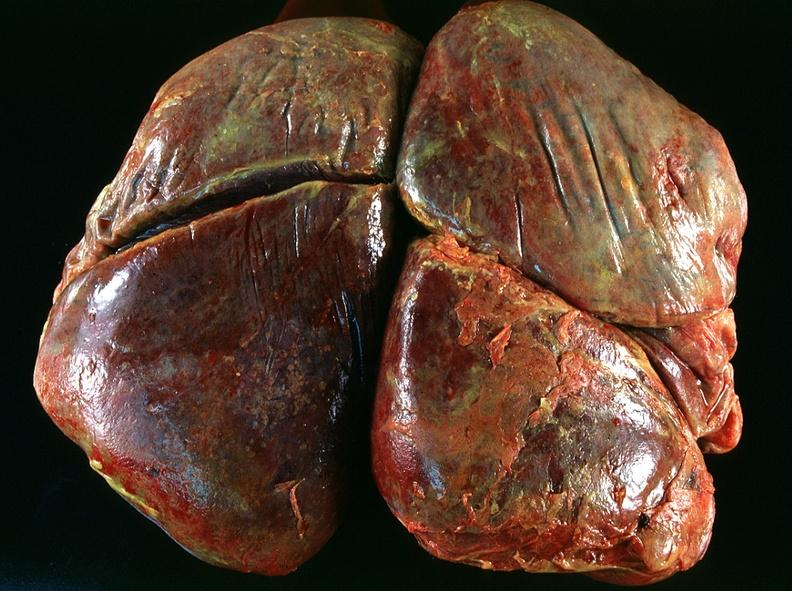what does this image show?
Answer the question using a single word or phrase. Lung 